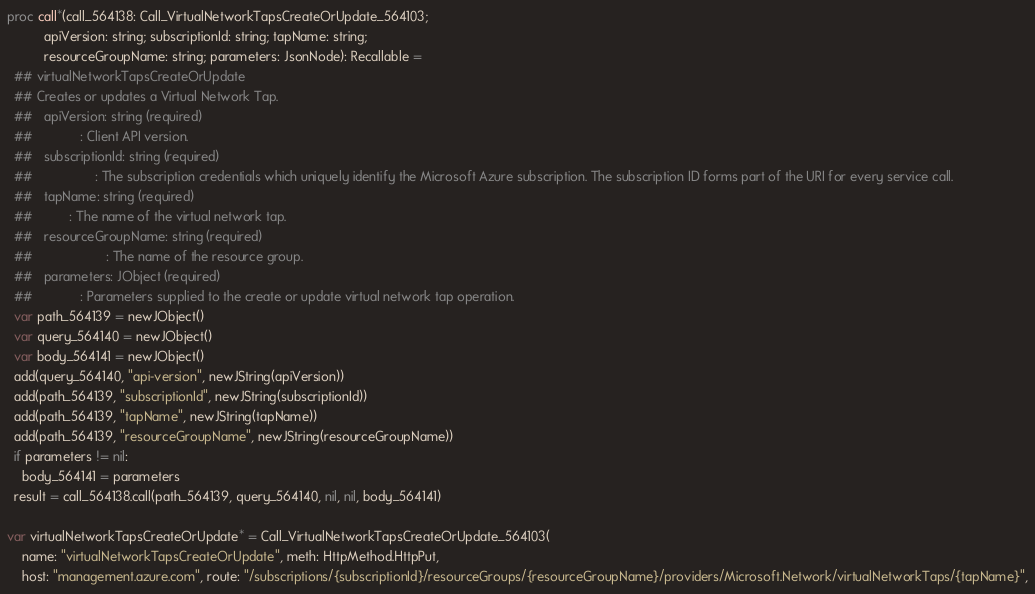Convert code to text. <code><loc_0><loc_0><loc_500><loc_500><_Nim_>
proc call*(call_564138: Call_VirtualNetworkTapsCreateOrUpdate_564103;
          apiVersion: string; subscriptionId: string; tapName: string;
          resourceGroupName: string; parameters: JsonNode): Recallable =
  ## virtualNetworkTapsCreateOrUpdate
  ## Creates or updates a Virtual Network Tap.
  ##   apiVersion: string (required)
  ##             : Client API version.
  ##   subscriptionId: string (required)
  ##                 : The subscription credentials which uniquely identify the Microsoft Azure subscription. The subscription ID forms part of the URI for every service call.
  ##   tapName: string (required)
  ##          : The name of the virtual network tap.
  ##   resourceGroupName: string (required)
  ##                    : The name of the resource group.
  ##   parameters: JObject (required)
  ##             : Parameters supplied to the create or update virtual network tap operation.
  var path_564139 = newJObject()
  var query_564140 = newJObject()
  var body_564141 = newJObject()
  add(query_564140, "api-version", newJString(apiVersion))
  add(path_564139, "subscriptionId", newJString(subscriptionId))
  add(path_564139, "tapName", newJString(tapName))
  add(path_564139, "resourceGroupName", newJString(resourceGroupName))
  if parameters != nil:
    body_564141 = parameters
  result = call_564138.call(path_564139, query_564140, nil, nil, body_564141)

var virtualNetworkTapsCreateOrUpdate* = Call_VirtualNetworkTapsCreateOrUpdate_564103(
    name: "virtualNetworkTapsCreateOrUpdate", meth: HttpMethod.HttpPut,
    host: "management.azure.com", route: "/subscriptions/{subscriptionId}/resourceGroups/{resourceGroupName}/providers/Microsoft.Network/virtualNetworkTaps/{tapName}",</code> 